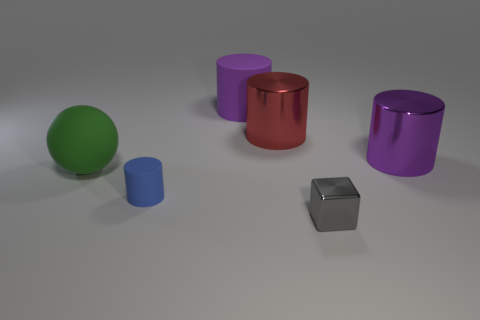Subtract all purple matte cylinders. How many cylinders are left? 3 Subtract all cyan cubes. How many purple cylinders are left? 2 Subtract 1 cylinders. How many cylinders are left? 3 Add 2 large purple cylinders. How many objects exist? 8 Subtract all purple cylinders. How many cylinders are left? 2 Subtract all blue cylinders. Subtract all gray blocks. How many cylinders are left? 3 Subtract all blocks. How many objects are left? 5 Subtract all tiny rubber objects. Subtract all big metal objects. How many objects are left? 3 Add 1 gray metal objects. How many gray metal objects are left? 2 Add 1 tiny brown metal objects. How many tiny brown metal objects exist? 1 